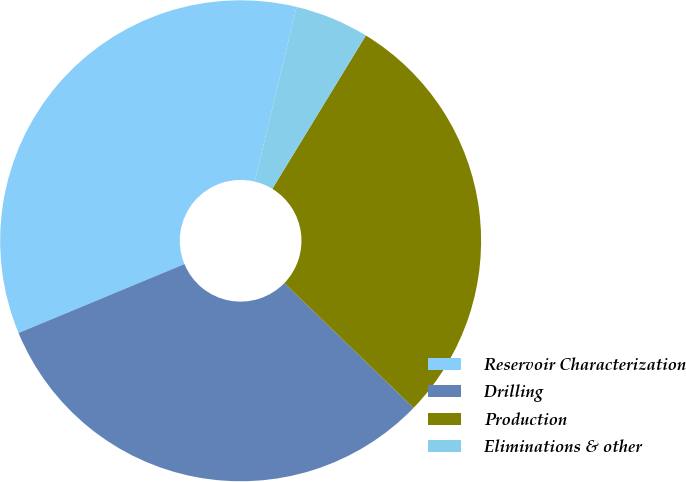Convert chart to OTSL. <chart><loc_0><loc_0><loc_500><loc_500><pie_chart><fcel>Reservoir Characterization<fcel>Drilling<fcel>Production<fcel>Eliminations & other<nl><fcel>35.0%<fcel>31.51%<fcel>28.51%<fcel>4.98%<nl></chart> 